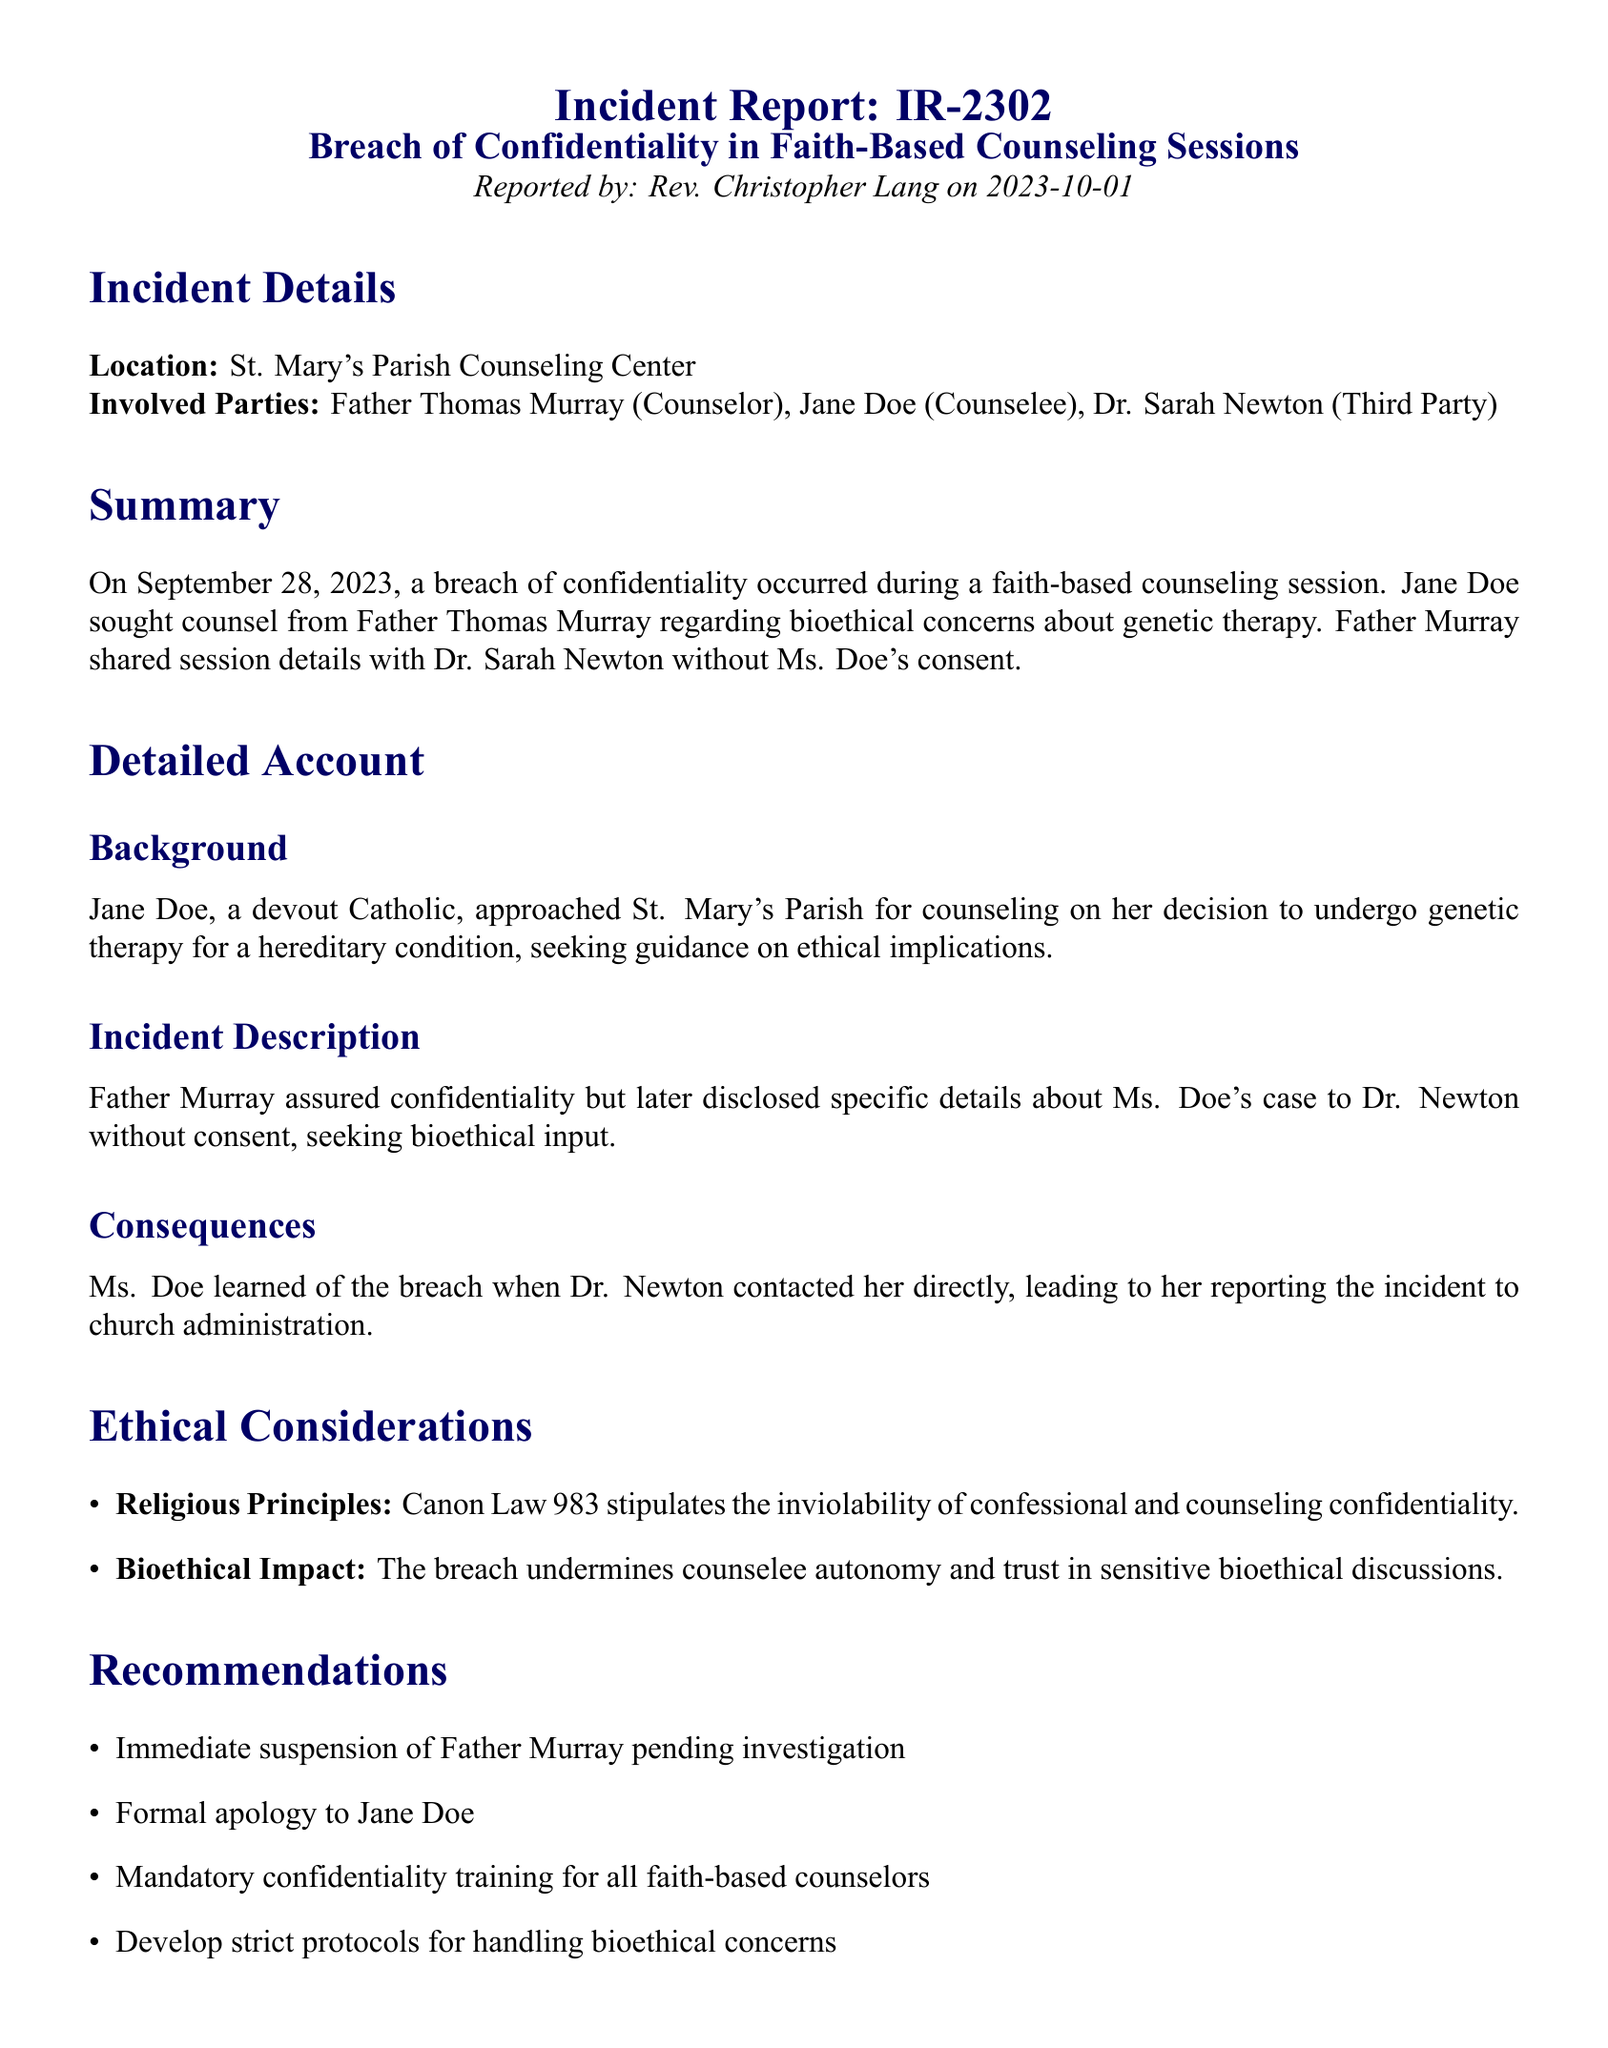What is the incident report number? The incident report number is stated at the beginning of the document as IR-2302.
Answer: IR-2302 Who reported the incident? The person who reported the incident is mentioned as Rev. Christopher Lang.
Answer: Rev. Christopher Lang What date did the breach of confidentiality occur? The document specifies that the breach occurred on September 28, 2023.
Answer: September 28, 2023 What was the primary concern discussed in the counseling session? The primary concern was about genetic therapy.
Answer: genetic therapy What canon law relates to confidentiality in counseling? The document references Canon Law 983 regarding confidentiality.
Answer: Canon Law 983 What consequences did Jane Doe face? Ms. Doe learned about the breach when contacted by Dr. Newton directly.
Answer: contacted by Dr. Newton What is one recommendation for addressing the issue? One recommendation is the immediate suspension of Father Murray pending investigation.
Answer: immediate suspension of Father Murray Who are the involved parties in the incident? The involved parties listed are Father Thomas Murray, Jane Doe, and Dr. Sarah Newton.
Answer: Father Thomas Murray, Jane Doe, Dr. Sarah Newton What should be developed to handle bioethical concerns according to the recommendations? The document states that strict protocols for handling bioethical concerns should be developed.
Answer: strict protocols for handling bioethical concerns 